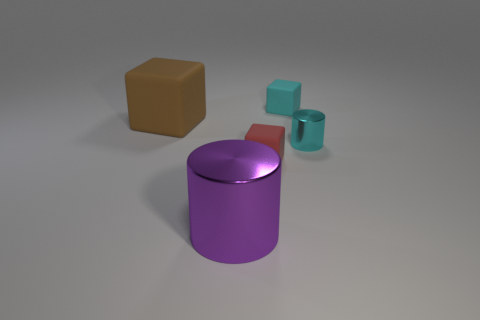Add 1 tiny cyan cubes. How many objects exist? 6 Subtract all blocks. How many objects are left? 2 Subtract all brown objects. Subtract all tiny cubes. How many objects are left? 2 Add 4 tiny cylinders. How many tiny cylinders are left? 5 Add 1 tiny cyan cylinders. How many tiny cyan cylinders exist? 2 Subtract 0 purple blocks. How many objects are left? 5 